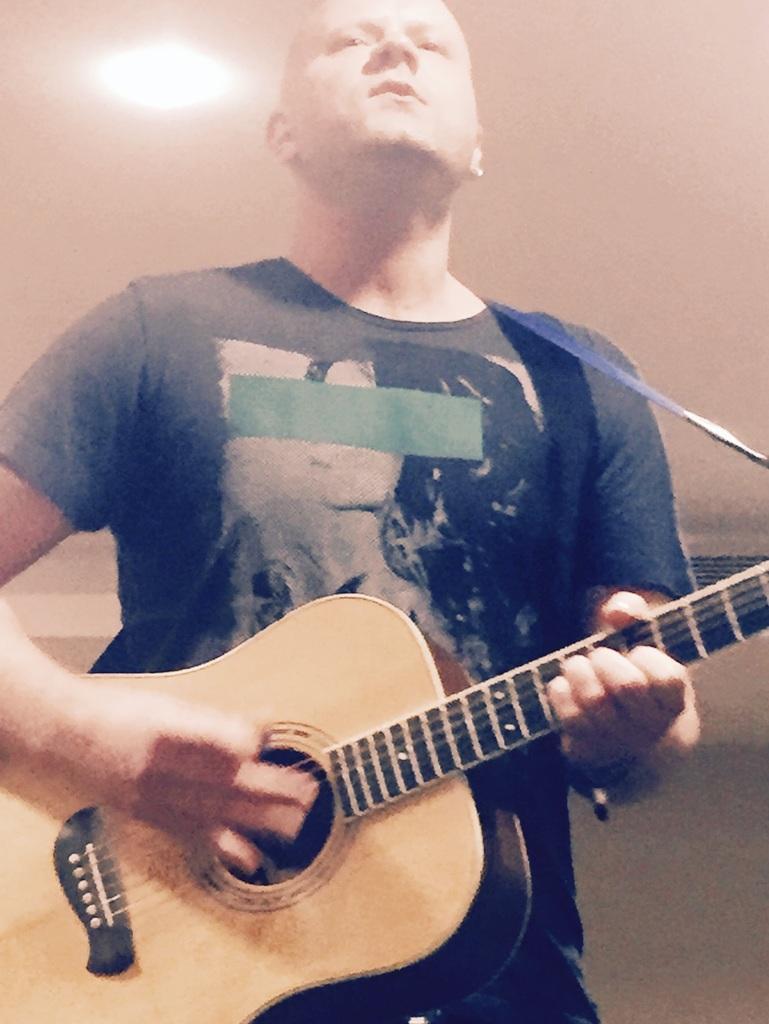Could you give a brief overview of what you see in this image? In this image I can see a man wearing black color t-shirt, standing and playing the guitar. In the background I can see a wall. On the top of the image there is a light. 